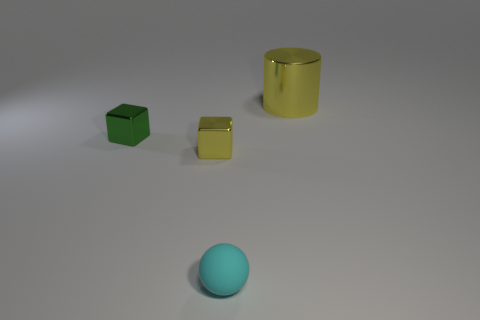What is the size of the green object that is made of the same material as the tiny yellow thing?
Your answer should be compact. Small. Is the shape of the small cyan thing the same as the small yellow thing?
Give a very brief answer. No. The other rubber thing that is the same size as the green thing is what color?
Keep it short and to the point. Cyan. There is a yellow thing that is the same shape as the tiny green thing; what is its size?
Ensure brevity in your answer.  Small. The yellow shiny object behind the small yellow block has what shape?
Your response must be concise. Cylinder. Does the tiny cyan object have the same shape as the big metallic object behind the small green thing?
Your response must be concise. No. Are there an equal number of small rubber things to the right of the cyan thing and green things that are left of the tiny yellow block?
Provide a short and direct response. No. What shape is the tiny object that is the same color as the big cylinder?
Offer a terse response. Cube. There is a metal object that is to the right of the yellow cube; is it the same color as the tiny cube that is in front of the green metallic cube?
Give a very brief answer. Yes. Are there more things that are behind the sphere than big yellow metal things?
Your answer should be compact. Yes. 